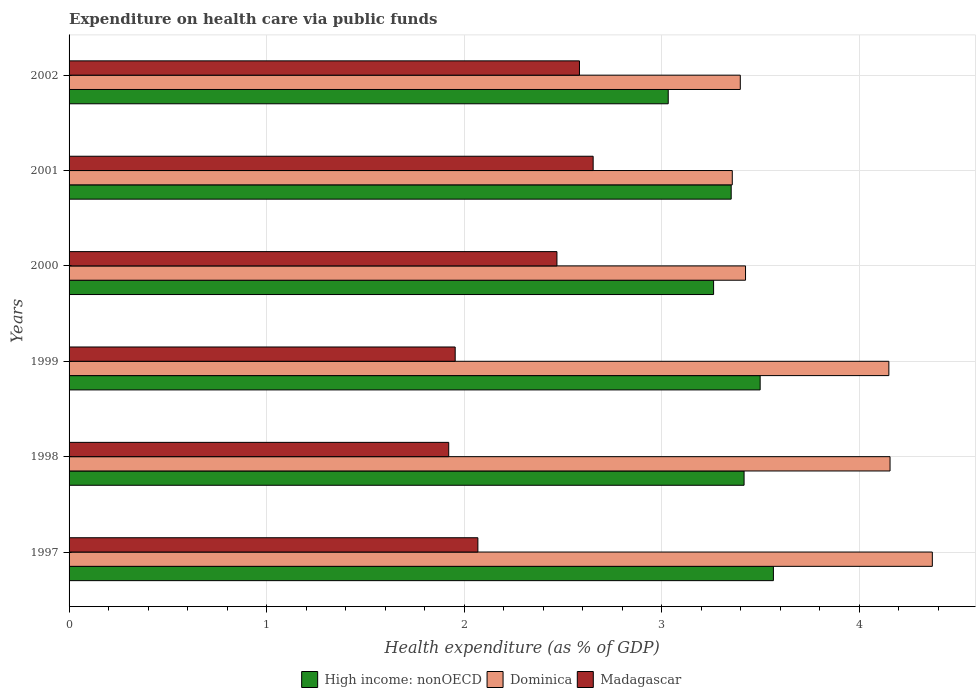Are the number of bars per tick equal to the number of legend labels?
Ensure brevity in your answer.  Yes. Are the number of bars on each tick of the Y-axis equal?
Offer a very short reply. Yes. How many bars are there on the 4th tick from the bottom?
Your answer should be compact. 3. In how many cases, is the number of bars for a given year not equal to the number of legend labels?
Offer a terse response. 0. What is the expenditure made on health care in Madagascar in 1999?
Offer a terse response. 1.95. Across all years, what is the maximum expenditure made on health care in High income: nonOECD?
Offer a terse response. 3.57. Across all years, what is the minimum expenditure made on health care in Madagascar?
Provide a succinct answer. 1.92. In which year was the expenditure made on health care in Madagascar maximum?
Your response must be concise. 2001. In which year was the expenditure made on health care in Madagascar minimum?
Make the answer very short. 1998. What is the total expenditure made on health care in Dominica in the graph?
Keep it short and to the point. 22.86. What is the difference between the expenditure made on health care in Dominica in 1997 and that in 1998?
Your answer should be very brief. 0.21. What is the difference between the expenditure made on health care in High income: nonOECD in 1998 and the expenditure made on health care in Dominica in 2002?
Offer a very short reply. 0.02. What is the average expenditure made on health care in High income: nonOECD per year?
Ensure brevity in your answer.  3.35. In the year 1997, what is the difference between the expenditure made on health care in Madagascar and expenditure made on health care in High income: nonOECD?
Make the answer very short. -1.5. What is the ratio of the expenditure made on health care in Madagascar in 1999 to that in 2000?
Your answer should be compact. 0.79. Is the difference between the expenditure made on health care in Madagascar in 1997 and 2002 greater than the difference between the expenditure made on health care in High income: nonOECD in 1997 and 2002?
Your answer should be compact. No. What is the difference between the highest and the second highest expenditure made on health care in High income: nonOECD?
Offer a terse response. 0.07. What is the difference between the highest and the lowest expenditure made on health care in High income: nonOECD?
Provide a succinct answer. 0.53. Is the sum of the expenditure made on health care in Madagascar in 1997 and 2001 greater than the maximum expenditure made on health care in Dominica across all years?
Your answer should be very brief. Yes. What does the 2nd bar from the top in 1999 represents?
Offer a very short reply. Dominica. What does the 2nd bar from the bottom in 2002 represents?
Provide a short and direct response. Dominica. Is it the case that in every year, the sum of the expenditure made on health care in Dominica and expenditure made on health care in High income: nonOECD is greater than the expenditure made on health care in Madagascar?
Offer a very short reply. Yes. How many bars are there?
Your answer should be very brief. 18. Are all the bars in the graph horizontal?
Provide a succinct answer. Yes. What is the difference between two consecutive major ticks on the X-axis?
Provide a short and direct response. 1. Where does the legend appear in the graph?
Offer a very short reply. Bottom center. How are the legend labels stacked?
Give a very brief answer. Horizontal. What is the title of the graph?
Provide a short and direct response. Expenditure on health care via public funds. Does "East Asia (developing only)" appear as one of the legend labels in the graph?
Your answer should be compact. No. What is the label or title of the X-axis?
Ensure brevity in your answer.  Health expenditure (as % of GDP). What is the Health expenditure (as % of GDP) of High income: nonOECD in 1997?
Your response must be concise. 3.57. What is the Health expenditure (as % of GDP) of Dominica in 1997?
Ensure brevity in your answer.  4.37. What is the Health expenditure (as % of GDP) in Madagascar in 1997?
Make the answer very short. 2.07. What is the Health expenditure (as % of GDP) in High income: nonOECD in 1998?
Provide a succinct answer. 3.42. What is the Health expenditure (as % of GDP) in Dominica in 1998?
Your answer should be very brief. 4.16. What is the Health expenditure (as % of GDP) in Madagascar in 1998?
Ensure brevity in your answer.  1.92. What is the Health expenditure (as % of GDP) of High income: nonOECD in 1999?
Offer a terse response. 3.5. What is the Health expenditure (as % of GDP) of Dominica in 1999?
Offer a terse response. 4.15. What is the Health expenditure (as % of GDP) of Madagascar in 1999?
Offer a very short reply. 1.95. What is the Health expenditure (as % of GDP) of High income: nonOECD in 2000?
Your answer should be compact. 3.26. What is the Health expenditure (as % of GDP) in Dominica in 2000?
Give a very brief answer. 3.42. What is the Health expenditure (as % of GDP) of Madagascar in 2000?
Give a very brief answer. 2.47. What is the Health expenditure (as % of GDP) in High income: nonOECD in 2001?
Your answer should be compact. 3.35. What is the Health expenditure (as % of GDP) in Dominica in 2001?
Offer a very short reply. 3.36. What is the Health expenditure (as % of GDP) of Madagascar in 2001?
Keep it short and to the point. 2.65. What is the Health expenditure (as % of GDP) of High income: nonOECD in 2002?
Offer a very short reply. 3.03. What is the Health expenditure (as % of GDP) in Dominica in 2002?
Keep it short and to the point. 3.4. What is the Health expenditure (as % of GDP) in Madagascar in 2002?
Your response must be concise. 2.58. Across all years, what is the maximum Health expenditure (as % of GDP) of High income: nonOECD?
Your answer should be compact. 3.57. Across all years, what is the maximum Health expenditure (as % of GDP) of Dominica?
Offer a very short reply. 4.37. Across all years, what is the maximum Health expenditure (as % of GDP) in Madagascar?
Make the answer very short. 2.65. Across all years, what is the minimum Health expenditure (as % of GDP) of High income: nonOECD?
Ensure brevity in your answer.  3.03. Across all years, what is the minimum Health expenditure (as % of GDP) in Dominica?
Keep it short and to the point. 3.36. Across all years, what is the minimum Health expenditure (as % of GDP) in Madagascar?
Make the answer very short. 1.92. What is the total Health expenditure (as % of GDP) of High income: nonOECD in the graph?
Give a very brief answer. 20.13. What is the total Health expenditure (as % of GDP) of Dominica in the graph?
Your answer should be compact. 22.86. What is the total Health expenditure (as % of GDP) in Madagascar in the graph?
Your answer should be very brief. 13.65. What is the difference between the Health expenditure (as % of GDP) in High income: nonOECD in 1997 and that in 1998?
Provide a short and direct response. 0.15. What is the difference between the Health expenditure (as % of GDP) of Dominica in 1997 and that in 1998?
Your response must be concise. 0.21. What is the difference between the Health expenditure (as % of GDP) of Madagascar in 1997 and that in 1998?
Offer a terse response. 0.15. What is the difference between the Health expenditure (as % of GDP) in High income: nonOECD in 1997 and that in 1999?
Provide a short and direct response. 0.07. What is the difference between the Health expenditure (as % of GDP) of Dominica in 1997 and that in 1999?
Offer a terse response. 0.22. What is the difference between the Health expenditure (as % of GDP) in Madagascar in 1997 and that in 1999?
Your answer should be very brief. 0.11. What is the difference between the Health expenditure (as % of GDP) of High income: nonOECD in 1997 and that in 2000?
Give a very brief answer. 0.3. What is the difference between the Health expenditure (as % of GDP) in Dominica in 1997 and that in 2000?
Your answer should be very brief. 0.95. What is the difference between the Health expenditure (as % of GDP) of Madagascar in 1997 and that in 2000?
Your answer should be compact. -0.4. What is the difference between the Health expenditure (as % of GDP) in High income: nonOECD in 1997 and that in 2001?
Keep it short and to the point. 0.21. What is the difference between the Health expenditure (as % of GDP) in Dominica in 1997 and that in 2001?
Make the answer very short. 1.01. What is the difference between the Health expenditure (as % of GDP) of Madagascar in 1997 and that in 2001?
Offer a terse response. -0.58. What is the difference between the Health expenditure (as % of GDP) of High income: nonOECD in 1997 and that in 2002?
Provide a short and direct response. 0.53. What is the difference between the Health expenditure (as % of GDP) of Dominica in 1997 and that in 2002?
Make the answer very short. 0.97. What is the difference between the Health expenditure (as % of GDP) of Madagascar in 1997 and that in 2002?
Your response must be concise. -0.51. What is the difference between the Health expenditure (as % of GDP) in High income: nonOECD in 1998 and that in 1999?
Offer a terse response. -0.08. What is the difference between the Health expenditure (as % of GDP) in Dominica in 1998 and that in 1999?
Keep it short and to the point. 0.01. What is the difference between the Health expenditure (as % of GDP) in Madagascar in 1998 and that in 1999?
Keep it short and to the point. -0.03. What is the difference between the Health expenditure (as % of GDP) of High income: nonOECD in 1998 and that in 2000?
Provide a short and direct response. 0.15. What is the difference between the Health expenditure (as % of GDP) in Dominica in 1998 and that in 2000?
Provide a short and direct response. 0.73. What is the difference between the Health expenditure (as % of GDP) in Madagascar in 1998 and that in 2000?
Make the answer very short. -0.55. What is the difference between the Health expenditure (as % of GDP) in High income: nonOECD in 1998 and that in 2001?
Your response must be concise. 0.07. What is the difference between the Health expenditure (as % of GDP) of Dominica in 1998 and that in 2001?
Your answer should be very brief. 0.8. What is the difference between the Health expenditure (as % of GDP) in Madagascar in 1998 and that in 2001?
Make the answer very short. -0.73. What is the difference between the Health expenditure (as % of GDP) in High income: nonOECD in 1998 and that in 2002?
Make the answer very short. 0.38. What is the difference between the Health expenditure (as % of GDP) of Dominica in 1998 and that in 2002?
Provide a short and direct response. 0.76. What is the difference between the Health expenditure (as % of GDP) in Madagascar in 1998 and that in 2002?
Keep it short and to the point. -0.66. What is the difference between the Health expenditure (as % of GDP) of High income: nonOECD in 1999 and that in 2000?
Provide a succinct answer. 0.24. What is the difference between the Health expenditure (as % of GDP) in Dominica in 1999 and that in 2000?
Provide a short and direct response. 0.73. What is the difference between the Health expenditure (as % of GDP) in Madagascar in 1999 and that in 2000?
Offer a very short reply. -0.52. What is the difference between the Health expenditure (as % of GDP) in High income: nonOECD in 1999 and that in 2001?
Your answer should be very brief. 0.15. What is the difference between the Health expenditure (as % of GDP) in Dominica in 1999 and that in 2001?
Provide a succinct answer. 0.79. What is the difference between the Health expenditure (as % of GDP) of Madagascar in 1999 and that in 2001?
Offer a terse response. -0.7. What is the difference between the Health expenditure (as % of GDP) in High income: nonOECD in 1999 and that in 2002?
Your answer should be compact. 0.47. What is the difference between the Health expenditure (as % of GDP) of Dominica in 1999 and that in 2002?
Make the answer very short. 0.75. What is the difference between the Health expenditure (as % of GDP) of Madagascar in 1999 and that in 2002?
Provide a succinct answer. -0.63. What is the difference between the Health expenditure (as % of GDP) of High income: nonOECD in 2000 and that in 2001?
Give a very brief answer. -0.09. What is the difference between the Health expenditure (as % of GDP) in Dominica in 2000 and that in 2001?
Offer a terse response. 0.07. What is the difference between the Health expenditure (as % of GDP) in Madagascar in 2000 and that in 2001?
Offer a terse response. -0.18. What is the difference between the Health expenditure (as % of GDP) of High income: nonOECD in 2000 and that in 2002?
Offer a very short reply. 0.23. What is the difference between the Health expenditure (as % of GDP) of Dominica in 2000 and that in 2002?
Your answer should be compact. 0.03. What is the difference between the Health expenditure (as % of GDP) in Madagascar in 2000 and that in 2002?
Provide a short and direct response. -0.11. What is the difference between the Health expenditure (as % of GDP) of High income: nonOECD in 2001 and that in 2002?
Offer a very short reply. 0.32. What is the difference between the Health expenditure (as % of GDP) in Dominica in 2001 and that in 2002?
Offer a very short reply. -0.04. What is the difference between the Health expenditure (as % of GDP) in Madagascar in 2001 and that in 2002?
Give a very brief answer. 0.07. What is the difference between the Health expenditure (as % of GDP) in High income: nonOECD in 1997 and the Health expenditure (as % of GDP) in Dominica in 1998?
Provide a succinct answer. -0.59. What is the difference between the Health expenditure (as % of GDP) in High income: nonOECD in 1997 and the Health expenditure (as % of GDP) in Madagascar in 1998?
Provide a succinct answer. 1.64. What is the difference between the Health expenditure (as % of GDP) in Dominica in 1997 and the Health expenditure (as % of GDP) in Madagascar in 1998?
Make the answer very short. 2.45. What is the difference between the Health expenditure (as % of GDP) of High income: nonOECD in 1997 and the Health expenditure (as % of GDP) of Dominica in 1999?
Your response must be concise. -0.58. What is the difference between the Health expenditure (as % of GDP) in High income: nonOECD in 1997 and the Health expenditure (as % of GDP) in Madagascar in 1999?
Ensure brevity in your answer.  1.61. What is the difference between the Health expenditure (as % of GDP) of Dominica in 1997 and the Health expenditure (as % of GDP) of Madagascar in 1999?
Provide a succinct answer. 2.42. What is the difference between the Health expenditure (as % of GDP) in High income: nonOECD in 1997 and the Health expenditure (as % of GDP) in Dominica in 2000?
Your answer should be very brief. 0.14. What is the difference between the Health expenditure (as % of GDP) in High income: nonOECD in 1997 and the Health expenditure (as % of GDP) in Madagascar in 2000?
Ensure brevity in your answer.  1.1. What is the difference between the Health expenditure (as % of GDP) in Dominica in 1997 and the Health expenditure (as % of GDP) in Madagascar in 2000?
Your response must be concise. 1.9. What is the difference between the Health expenditure (as % of GDP) in High income: nonOECD in 1997 and the Health expenditure (as % of GDP) in Dominica in 2001?
Give a very brief answer. 0.21. What is the difference between the Health expenditure (as % of GDP) of High income: nonOECD in 1997 and the Health expenditure (as % of GDP) of Madagascar in 2001?
Your answer should be very brief. 0.91. What is the difference between the Health expenditure (as % of GDP) of Dominica in 1997 and the Health expenditure (as % of GDP) of Madagascar in 2001?
Ensure brevity in your answer.  1.72. What is the difference between the Health expenditure (as % of GDP) of High income: nonOECD in 1997 and the Health expenditure (as % of GDP) of Dominica in 2002?
Your answer should be compact. 0.17. What is the difference between the Health expenditure (as % of GDP) of High income: nonOECD in 1997 and the Health expenditure (as % of GDP) of Madagascar in 2002?
Offer a terse response. 0.98. What is the difference between the Health expenditure (as % of GDP) of Dominica in 1997 and the Health expenditure (as % of GDP) of Madagascar in 2002?
Offer a very short reply. 1.79. What is the difference between the Health expenditure (as % of GDP) of High income: nonOECD in 1998 and the Health expenditure (as % of GDP) of Dominica in 1999?
Keep it short and to the point. -0.73. What is the difference between the Health expenditure (as % of GDP) in High income: nonOECD in 1998 and the Health expenditure (as % of GDP) in Madagascar in 1999?
Make the answer very short. 1.46. What is the difference between the Health expenditure (as % of GDP) in Dominica in 1998 and the Health expenditure (as % of GDP) in Madagascar in 1999?
Your response must be concise. 2.2. What is the difference between the Health expenditure (as % of GDP) in High income: nonOECD in 1998 and the Health expenditure (as % of GDP) in Dominica in 2000?
Make the answer very short. -0.01. What is the difference between the Health expenditure (as % of GDP) in High income: nonOECD in 1998 and the Health expenditure (as % of GDP) in Madagascar in 2000?
Ensure brevity in your answer.  0.95. What is the difference between the Health expenditure (as % of GDP) of Dominica in 1998 and the Health expenditure (as % of GDP) of Madagascar in 2000?
Your response must be concise. 1.69. What is the difference between the Health expenditure (as % of GDP) of High income: nonOECD in 1998 and the Health expenditure (as % of GDP) of Dominica in 2001?
Your answer should be compact. 0.06. What is the difference between the Health expenditure (as % of GDP) in High income: nonOECD in 1998 and the Health expenditure (as % of GDP) in Madagascar in 2001?
Provide a succinct answer. 0.76. What is the difference between the Health expenditure (as % of GDP) in Dominica in 1998 and the Health expenditure (as % of GDP) in Madagascar in 2001?
Your answer should be very brief. 1.5. What is the difference between the Health expenditure (as % of GDP) in High income: nonOECD in 1998 and the Health expenditure (as % of GDP) in Dominica in 2002?
Your answer should be compact. 0.02. What is the difference between the Health expenditure (as % of GDP) in Dominica in 1998 and the Health expenditure (as % of GDP) in Madagascar in 2002?
Your answer should be compact. 1.57. What is the difference between the Health expenditure (as % of GDP) of High income: nonOECD in 1999 and the Health expenditure (as % of GDP) of Dominica in 2000?
Make the answer very short. 0.07. What is the difference between the Health expenditure (as % of GDP) of High income: nonOECD in 1999 and the Health expenditure (as % of GDP) of Madagascar in 2000?
Your answer should be compact. 1.03. What is the difference between the Health expenditure (as % of GDP) of Dominica in 1999 and the Health expenditure (as % of GDP) of Madagascar in 2000?
Offer a very short reply. 1.68. What is the difference between the Health expenditure (as % of GDP) of High income: nonOECD in 1999 and the Health expenditure (as % of GDP) of Dominica in 2001?
Give a very brief answer. 0.14. What is the difference between the Health expenditure (as % of GDP) of High income: nonOECD in 1999 and the Health expenditure (as % of GDP) of Madagascar in 2001?
Your answer should be very brief. 0.85. What is the difference between the Health expenditure (as % of GDP) in Dominica in 1999 and the Health expenditure (as % of GDP) in Madagascar in 2001?
Your response must be concise. 1.5. What is the difference between the Health expenditure (as % of GDP) in High income: nonOECD in 1999 and the Health expenditure (as % of GDP) in Dominica in 2002?
Your response must be concise. 0.1. What is the difference between the Health expenditure (as % of GDP) of High income: nonOECD in 1999 and the Health expenditure (as % of GDP) of Madagascar in 2002?
Provide a short and direct response. 0.91. What is the difference between the Health expenditure (as % of GDP) in Dominica in 1999 and the Health expenditure (as % of GDP) in Madagascar in 2002?
Ensure brevity in your answer.  1.57. What is the difference between the Health expenditure (as % of GDP) of High income: nonOECD in 2000 and the Health expenditure (as % of GDP) of Dominica in 2001?
Keep it short and to the point. -0.09. What is the difference between the Health expenditure (as % of GDP) of High income: nonOECD in 2000 and the Health expenditure (as % of GDP) of Madagascar in 2001?
Give a very brief answer. 0.61. What is the difference between the Health expenditure (as % of GDP) of Dominica in 2000 and the Health expenditure (as % of GDP) of Madagascar in 2001?
Provide a succinct answer. 0.77. What is the difference between the Health expenditure (as % of GDP) of High income: nonOECD in 2000 and the Health expenditure (as % of GDP) of Dominica in 2002?
Ensure brevity in your answer.  -0.14. What is the difference between the Health expenditure (as % of GDP) in High income: nonOECD in 2000 and the Health expenditure (as % of GDP) in Madagascar in 2002?
Give a very brief answer. 0.68. What is the difference between the Health expenditure (as % of GDP) in Dominica in 2000 and the Health expenditure (as % of GDP) in Madagascar in 2002?
Your answer should be compact. 0.84. What is the difference between the Health expenditure (as % of GDP) in High income: nonOECD in 2001 and the Health expenditure (as % of GDP) in Dominica in 2002?
Give a very brief answer. -0.05. What is the difference between the Health expenditure (as % of GDP) in High income: nonOECD in 2001 and the Health expenditure (as % of GDP) in Madagascar in 2002?
Ensure brevity in your answer.  0.77. What is the difference between the Health expenditure (as % of GDP) of Dominica in 2001 and the Health expenditure (as % of GDP) of Madagascar in 2002?
Make the answer very short. 0.77. What is the average Health expenditure (as % of GDP) in High income: nonOECD per year?
Make the answer very short. 3.35. What is the average Health expenditure (as % of GDP) in Dominica per year?
Offer a terse response. 3.81. What is the average Health expenditure (as % of GDP) in Madagascar per year?
Your answer should be very brief. 2.28. In the year 1997, what is the difference between the Health expenditure (as % of GDP) of High income: nonOECD and Health expenditure (as % of GDP) of Dominica?
Ensure brevity in your answer.  -0.8. In the year 1997, what is the difference between the Health expenditure (as % of GDP) in High income: nonOECD and Health expenditure (as % of GDP) in Madagascar?
Keep it short and to the point. 1.5. In the year 1997, what is the difference between the Health expenditure (as % of GDP) of Dominica and Health expenditure (as % of GDP) of Madagascar?
Keep it short and to the point. 2.3. In the year 1998, what is the difference between the Health expenditure (as % of GDP) of High income: nonOECD and Health expenditure (as % of GDP) of Dominica?
Ensure brevity in your answer.  -0.74. In the year 1998, what is the difference between the Health expenditure (as % of GDP) in High income: nonOECD and Health expenditure (as % of GDP) in Madagascar?
Offer a terse response. 1.5. In the year 1998, what is the difference between the Health expenditure (as % of GDP) of Dominica and Health expenditure (as % of GDP) of Madagascar?
Give a very brief answer. 2.23. In the year 1999, what is the difference between the Health expenditure (as % of GDP) in High income: nonOECD and Health expenditure (as % of GDP) in Dominica?
Your response must be concise. -0.65. In the year 1999, what is the difference between the Health expenditure (as % of GDP) of High income: nonOECD and Health expenditure (as % of GDP) of Madagascar?
Make the answer very short. 1.54. In the year 1999, what is the difference between the Health expenditure (as % of GDP) of Dominica and Health expenditure (as % of GDP) of Madagascar?
Provide a succinct answer. 2.2. In the year 2000, what is the difference between the Health expenditure (as % of GDP) of High income: nonOECD and Health expenditure (as % of GDP) of Dominica?
Make the answer very short. -0.16. In the year 2000, what is the difference between the Health expenditure (as % of GDP) in High income: nonOECD and Health expenditure (as % of GDP) in Madagascar?
Keep it short and to the point. 0.79. In the year 2000, what is the difference between the Health expenditure (as % of GDP) in Dominica and Health expenditure (as % of GDP) in Madagascar?
Offer a terse response. 0.95. In the year 2001, what is the difference between the Health expenditure (as % of GDP) in High income: nonOECD and Health expenditure (as % of GDP) in Dominica?
Offer a very short reply. -0.01. In the year 2001, what is the difference between the Health expenditure (as % of GDP) of High income: nonOECD and Health expenditure (as % of GDP) of Madagascar?
Provide a succinct answer. 0.7. In the year 2001, what is the difference between the Health expenditure (as % of GDP) in Dominica and Health expenditure (as % of GDP) in Madagascar?
Your response must be concise. 0.7. In the year 2002, what is the difference between the Health expenditure (as % of GDP) in High income: nonOECD and Health expenditure (as % of GDP) in Dominica?
Offer a terse response. -0.36. In the year 2002, what is the difference between the Health expenditure (as % of GDP) of High income: nonOECD and Health expenditure (as % of GDP) of Madagascar?
Ensure brevity in your answer.  0.45. In the year 2002, what is the difference between the Health expenditure (as % of GDP) of Dominica and Health expenditure (as % of GDP) of Madagascar?
Ensure brevity in your answer.  0.81. What is the ratio of the Health expenditure (as % of GDP) of High income: nonOECD in 1997 to that in 1998?
Offer a very short reply. 1.04. What is the ratio of the Health expenditure (as % of GDP) in Dominica in 1997 to that in 1998?
Your response must be concise. 1.05. What is the ratio of the Health expenditure (as % of GDP) of Madagascar in 1997 to that in 1998?
Give a very brief answer. 1.08. What is the ratio of the Health expenditure (as % of GDP) in High income: nonOECD in 1997 to that in 1999?
Offer a very short reply. 1.02. What is the ratio of the Health expenditure (as % of GDP) of Dominica in 1997 to that in 1999?
Your answer should be very brief. 1.05. What is the ratio of the Health expenditure (as % of GDP) in Madagascar in 1997 to that in 1999?
Your answer should be very brief. 1.06. What is the ratio of the Health expenditure (as % of GDP) of High income: nonOECD in 1997 to that in 2000?
Provide a short and direct response. 1.09. What is the ratio of the Health expenditure (as % of GDP) of Dominica in 1997 to that in 2000?
Your answer should be compact. 1.28. What is the ratio of the Health expenditure (as % of GDP) of Madagascar in 1997 to that in 2000?
Your response must be concise. 0.84. What is the ratio of the Health expenditure (as % of GDP) of High income: nonOECD in 1997 to that in 2001?
Provide a succinct answer. 1.06. What is the ratio of the Health expenditure (as % of GDP) in Dominica in 1997 to that in 2001?
Offer a very short reply. 1.3. What is the ratio of the Health expenditure (as % of GDP) of Madagascar in 1997 to that in 2001?
Your response must be concise. 0.78. What is the ratio of the Health expenditure (as % of GDP) in High income: nonOECD in 1997 to that in 2002?
Your answer should be very brief. 1.18. What is the ratio of the Health expenditure (as % of GDP) of Dominica in 1997 to that in 2002?
Make the answer very short. 1.29. What is the ratio of the Health expenditure (as % of GDP) of Madagascar in 1997 to that in 2002?
Offer a terse response. 0.8. What is the ratio of the Health expenditure (as % of GDP) in High income: nonOECD in 1998 to that in 1999?
Offer a terse response. 0.98. What is the ratio of the Health expenditure (as % of GDP) of Madagascar in 1998 to that in 1999?
Provide a short and direct response. 0.98. What is the ratio of the Health expenditure (as % of GDP) in High income: nonOECD in 1998 to that in 2000?
Offer a terse response. 1.05. What is the ratio of the Health expenditure (as % of GDP) in Dominica in 1998 to that in 2000?
Make the answer very short. 1.21. What is the ratio of the Health expenditure (as % of GDP) in Madagascar in 1998 to that in 2000?
Offer a very short reply. 0.78. What is the ratio of the Health expenditure (as % of GDP) in High income: nonOECD in 1998 to that in 2001?
Your answer should be very brief. 1.02. What is the ratio of the Health expenditure (as % of GDP) of Dominica in 1998 to that in 2001?
Your answer should be very brief. 1.24. What is the ratio of the Health expenditure (as % of GDP) of Madagascar in 1998 to that in 2001?
Provide a short and direct response. 0.72. What is the ratio of the Health expenditure (as % of GDP) of High income: nonOECD in 1998 to that in 2002?
Keep it short and to the point. 1.13. What is the ratio of the Health expenditure (as % of GDP) of Dominica in 1998 to that in 2002?
Your answer should be compact. 1.22. What is the ratio of the Health expenditure (as % of GDP) in Madagascar in 1998 to that in 2002?
Ensure brevity in your answer.  0.74. What is the ratio of the Health expenditure (as % of GDP) in High income: nonOECD in 1999 to that in 2000?
Give a very brief answer. 1.07. What is the ratio of the Health expenditure (as % of GDP) in Dominica in 1999 to that in 2000?
Make the answer very short. 1.21. What is the ratio of the Health expenditure (as % of GDP) of Madagascar in 1999 to that in 2000?
Offer a very short reply. 0.79. What is the ratio of the Health expenditure (as % of GDP) of High income: nonOECD in 1999 to that in 2001?
Provide a succinct answer. 1.04. What is the ratio of the Health expenditure (as % of GDP) in Dominica in 1999 to that in 2001?
Your response must be concise. 1.24. What is the ratio of the Health expenditure (as % of GDP) of Madagascar in 1999 to that in 2001?
Your answer should be very brief. 0.74. What is the ratio of the Health expenditure (as % of GDP) of High income: nonOECD in 1999 to that in 2002?
Make the answer very short. 1.15. What is the ratio of the Health expenditure (as % of GDP) in Dominica in 1999 to that in 2002?
Your answer should be very brief. 1.22. What is the ratio of the Health expenditure (as % of GDP) in Madagascar in 1999 to that in 2002?
Offer a terse response. 0.76. What is the ratio of the Health expenditure (as % of GDP) of High income: nonOECD in 2000 to that in 2001?
Offer a very short reply. 0.97. What is the ratio of the Health expenditure (as % of GDP) of Madagascar in 2000 to that in 2001?
Provide a short and direct response. 0.93. What is the ratio of the Health expenditure (as % of GDP) of High income: nonOECD in 2000 to that in 2002?
Your answer should be very brief. 1.08. What is the ratio of the Health expenditure (as % of GDP) in Madagascar in 2000 to that in 2002?
Make the answer very short. 0.96. What is the ratio of the Health expenditure (as % of GDP) in High income: nonOECD in 2001 to that in 2002?
Make the answer very short. 1.11. What is the ratio of the Health expenditure (as % of GDP) in Madagascar in 2001 to that in 2002?
Your response must be concise. 1.03. What is the difference between the highest and the second highest Health expenditure (as % of GDP) of High income: nonOECD?
Keep it short and to the point. 0.07. What is the difference between the highest and the second highest Health expenditure (as % of GDP) in Dominica?
Your answer should be compact. 0.21. What is the difference between the highest and the second highest Health expenditure (as % of GDP) of Madagascar?
Provide a short and direct response. 0.07. What is the difference between the highest and the lowest Health expenditure (as % of GDP) in High income: nonOECD?
Give a very brief answer. 0.53. What is the difference between the highest and the lowest Health expenditure (as % of GDP) in Dominica?
Give a very brief answer. 1.01. What is the difference between the highest and the lowest Health expenditure (as % of GDP) in Madagascar?
Ensure brevity in your answer.  0.73. 